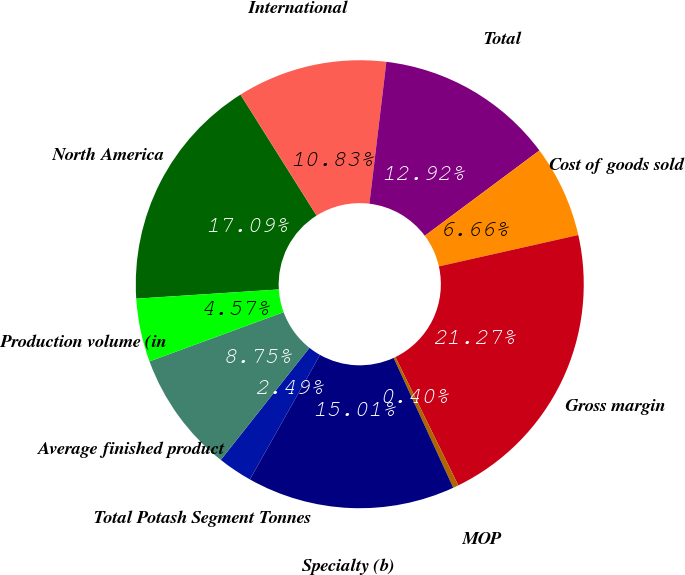<chart> <loc_0><loc_0><loc_500><loc_500><pie_chart><fcel>North America<fcel>International<fcel>Total<fcel>Cost of goods sold<fcel>Gross margin<fcel>MOP<fcel>Specialty (b)<fcel>Total Potash Segment Tonnes<fcel>Average finished product<fcel>Production volume (in<nl><fcel>17.09%<fcel>10.83%<fcel>12.92%<fcel>6.66%<fcel>21.27%<fcel>0.4%<fcel>15.01%<fcel>2.49%<fcel>8.75%<fcel>4.57%<nl></chart> 